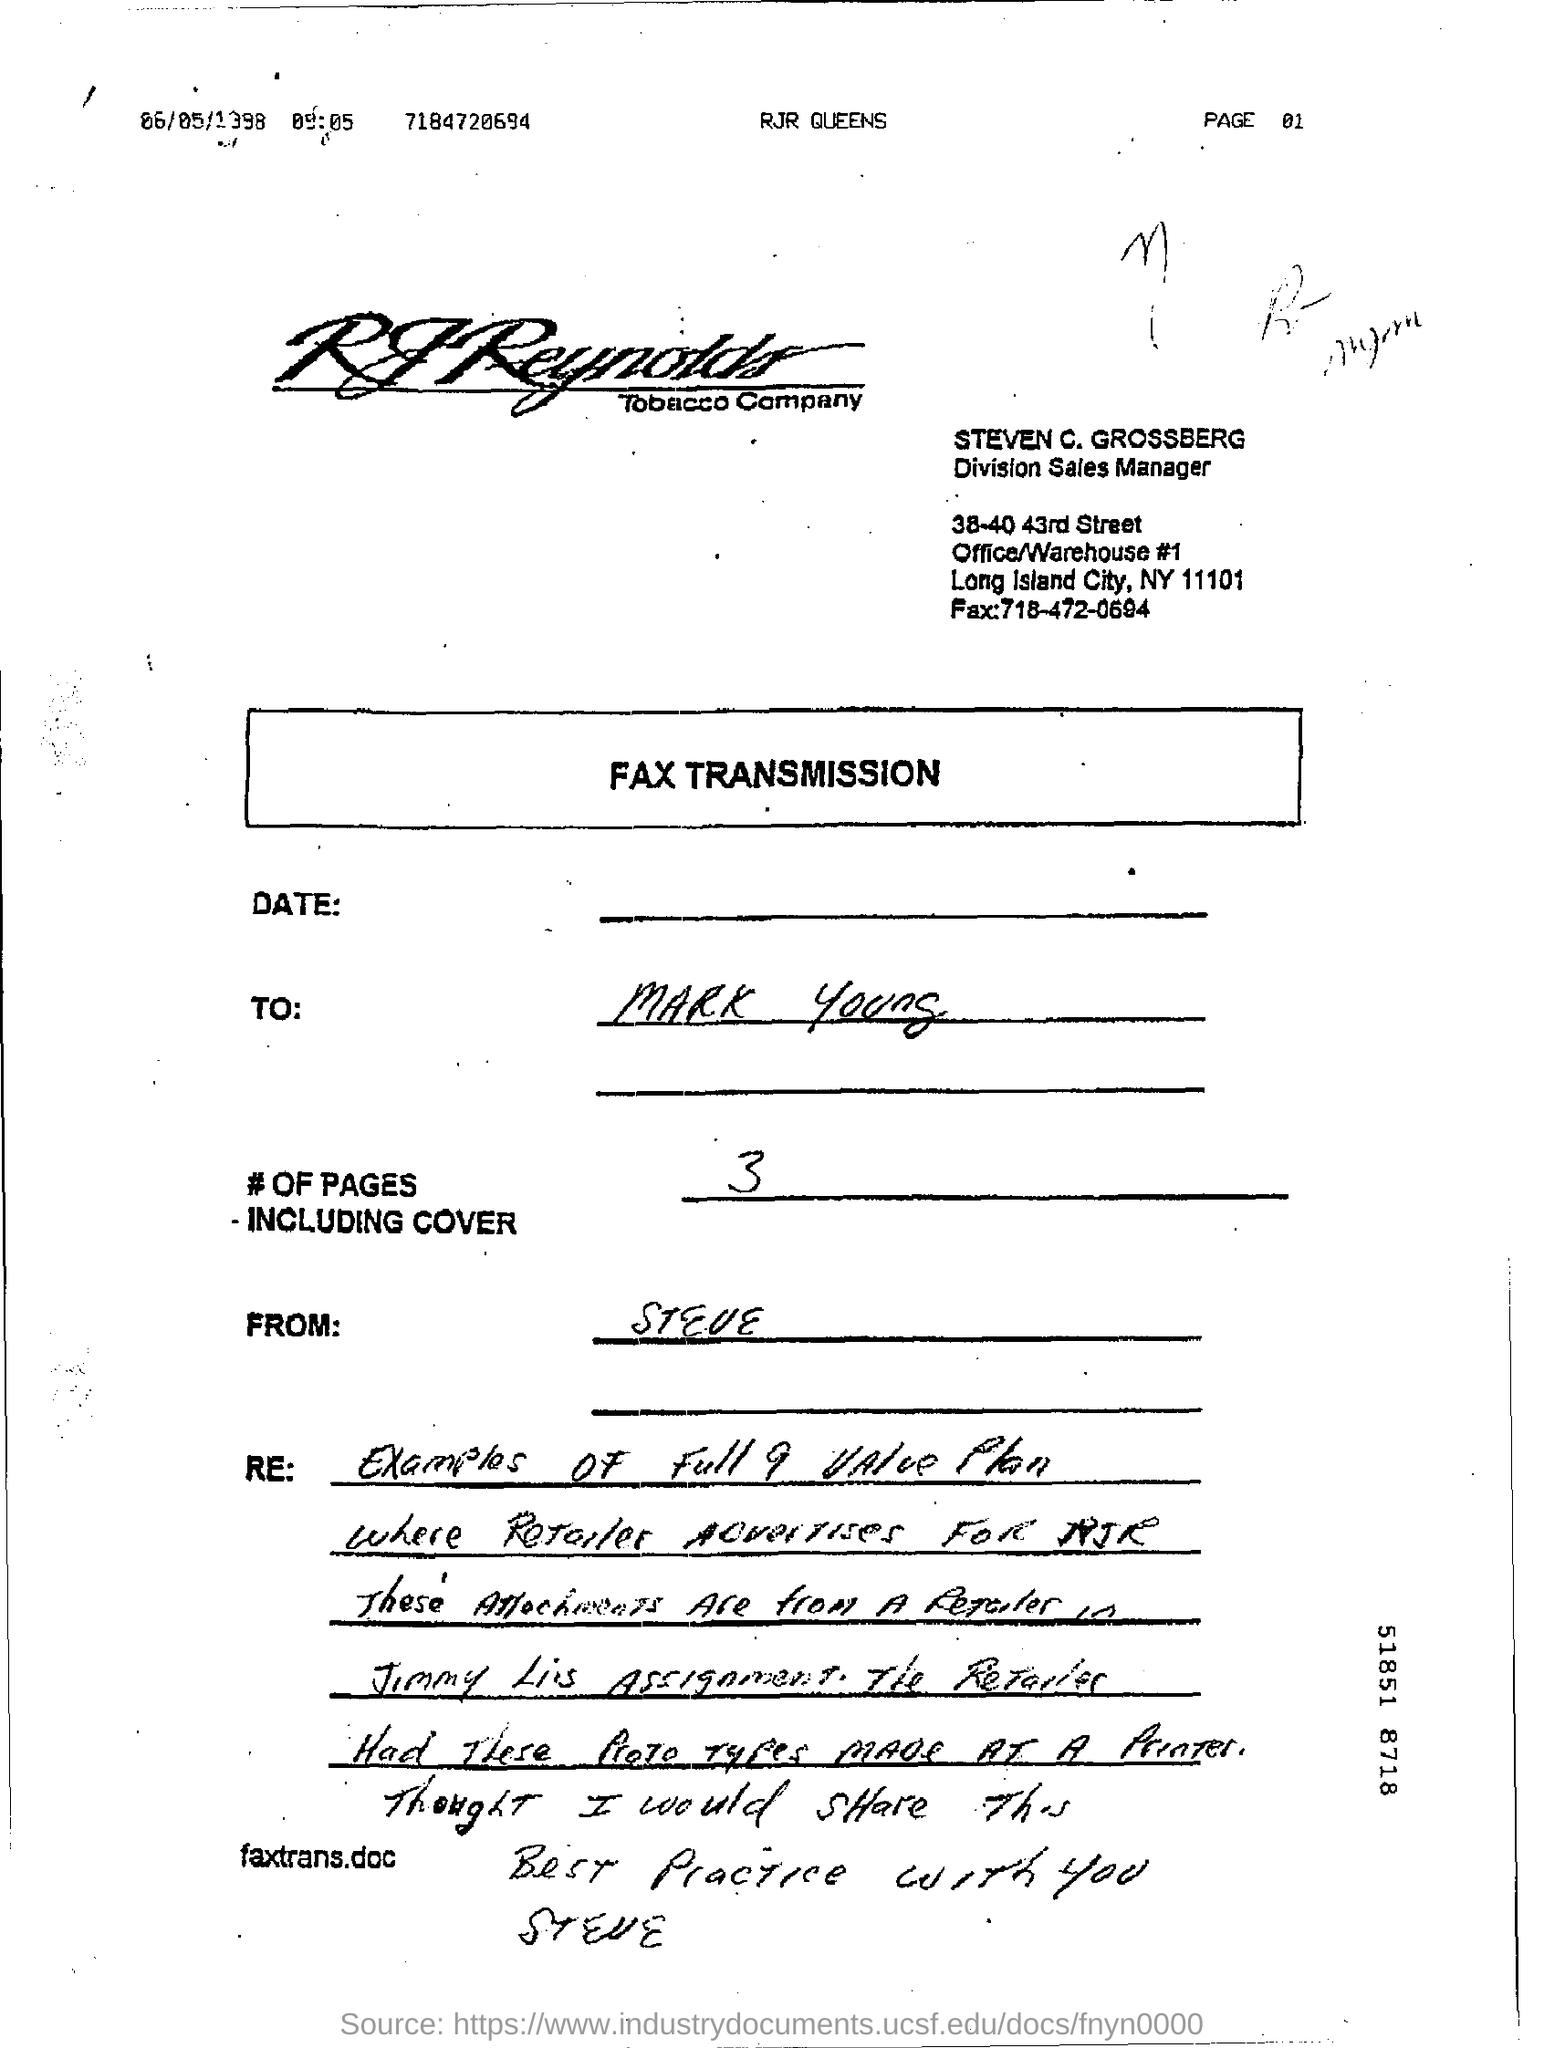Identify some key points in this picture. The number of pages in the fax, including the cover page, is three. The recipient of the fax is Mark Young. The fax transmission in question belongs to RJ Reynolds Tobacco Company. Steven C. Grossberg's designation is that of a division sales manager. The fax number of Steven C. Grossberg is 718-472-0694. 